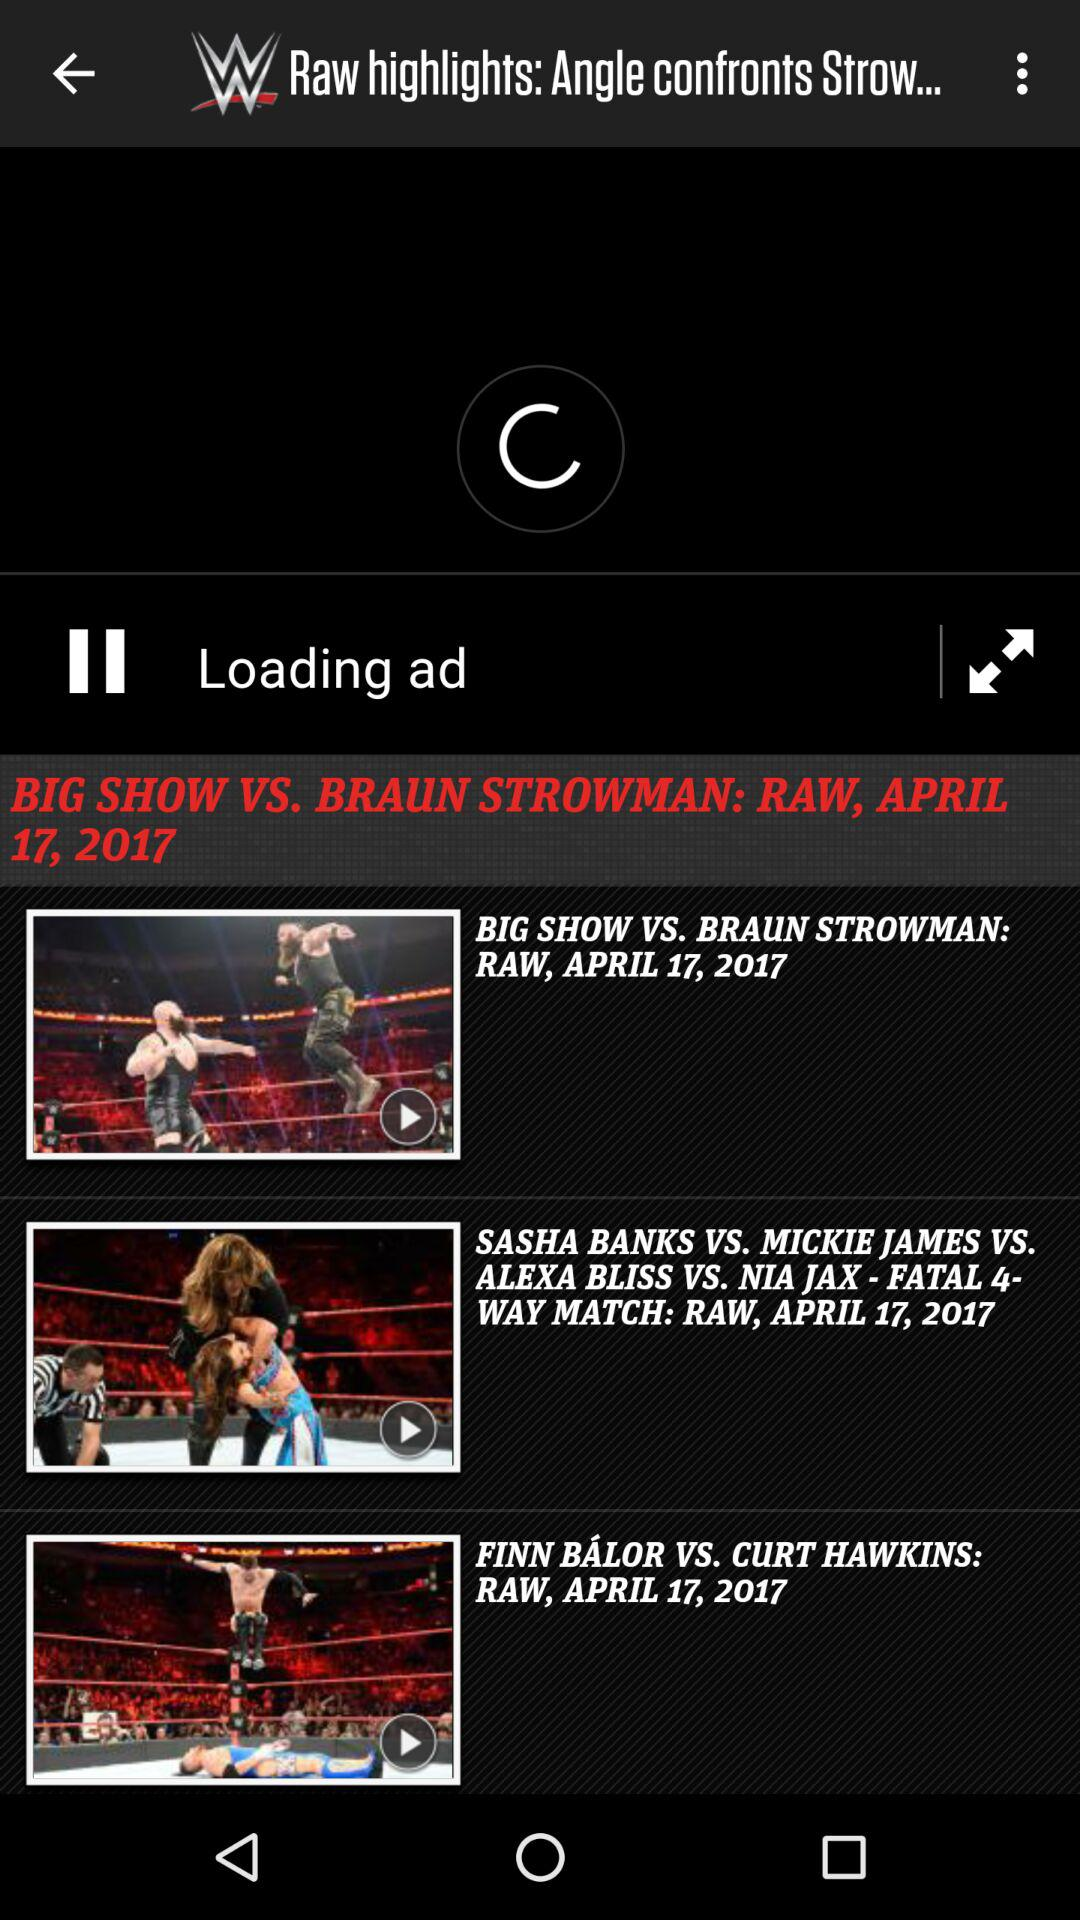What was the date of the match between Big Show and Braun Strowman? The date was April 17, 2017. 